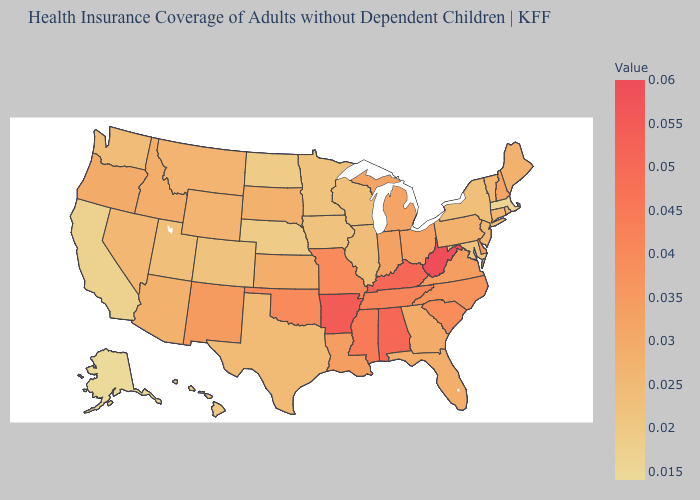Does New Mexico have the highest value in the West?
Keep it brief. Yes. Does California have the lowest value in the USA?
Keep it brief. No. Does Nebraska have the lowest value in the USA?
Be succinct. No. Is the legend a continuous bar?
Answer briefly. Yes. Among the states that border Washington , does Idaho have the highest value?
Be succinct. No. Is the legend a continuous bar?
Be succinct. Yes. Is the legend a continuous bar?
Answer briefly. Yes. Does New Jersey have the lowest value in the Northeast?
Short answer required. No. 